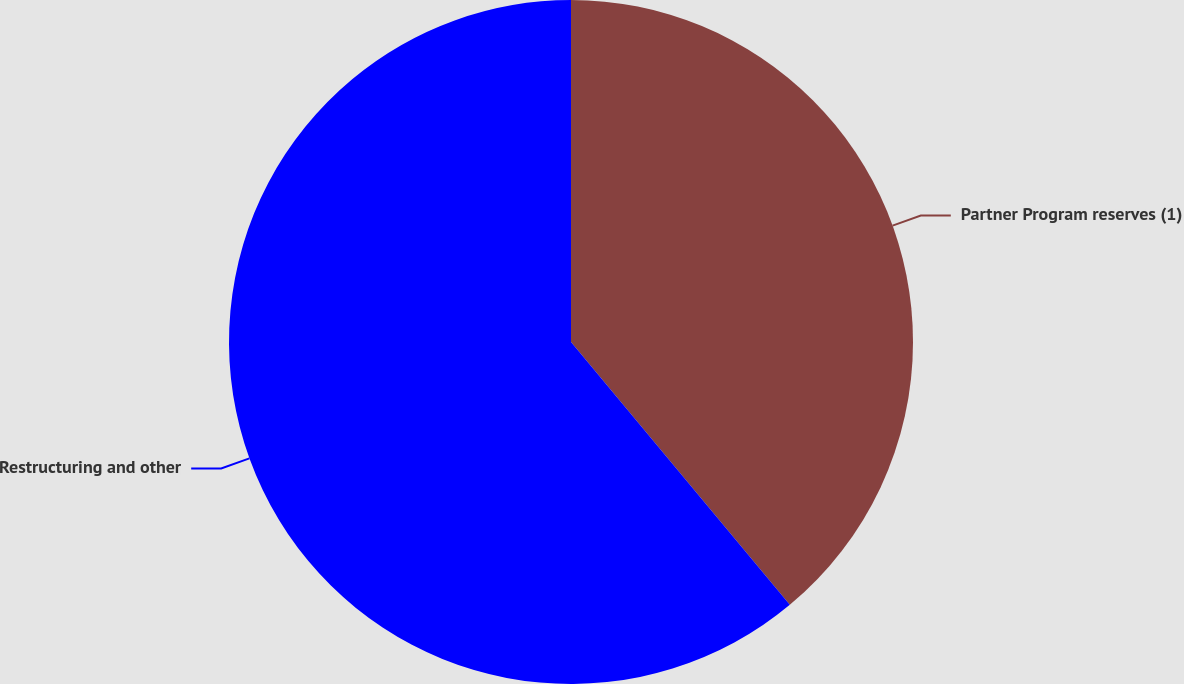Convert chart. <chart><loc_0><loc_0><loc_500><loc_500><pie_chart><fcel>Partner Program reserves (1)<fcel>Restructuring and other<nl><fcel>38.95%<fcel>61.05%<nl></chart> 